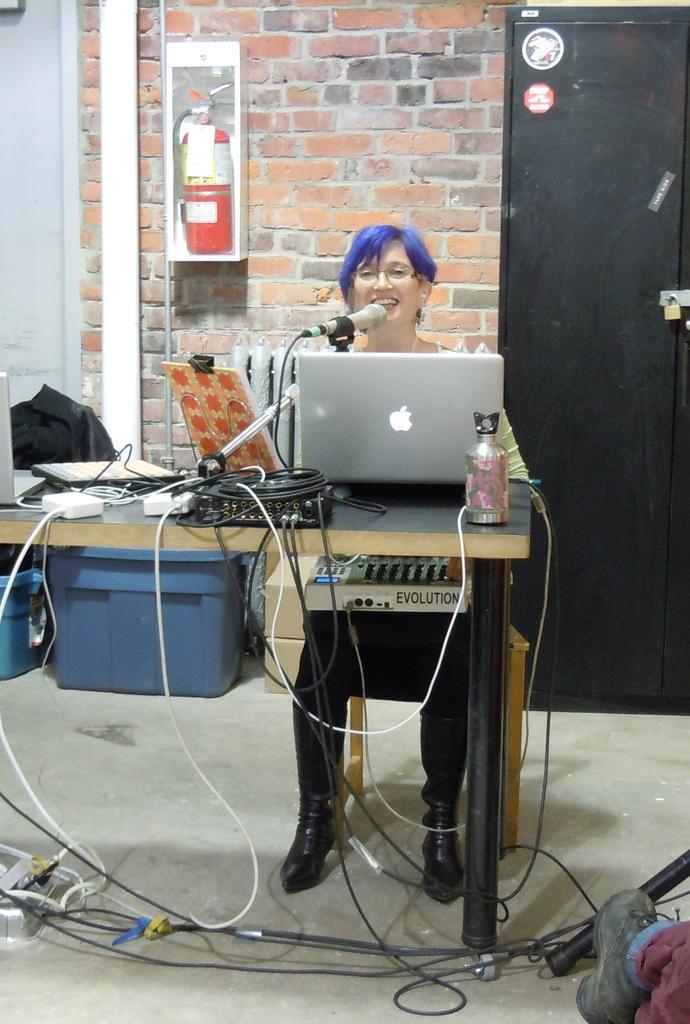Describe this image in one or two sentences. In this picture we can observe a table on which there is a laptop, mic, adapters and water bottle. We can observe white and black color wires. In front of a table there is a woman sitting in the chair and smiling. We can observe a fire extinguisher fixed to the wall. On the right side there is a black color door. 